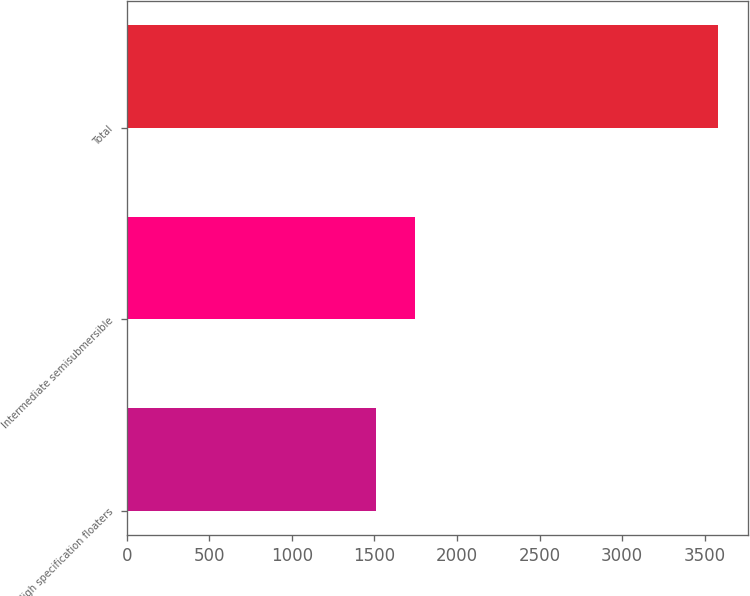Convert chart. <chart><loc_0><loc_0><loc_500><loc_500><bar_chart><fcel>High specification floaters<fcel>Intermediate semisubmersible<fcel>Total<nl><fcel>1507<fcel>1747<fcel>3583<nl></chart> 